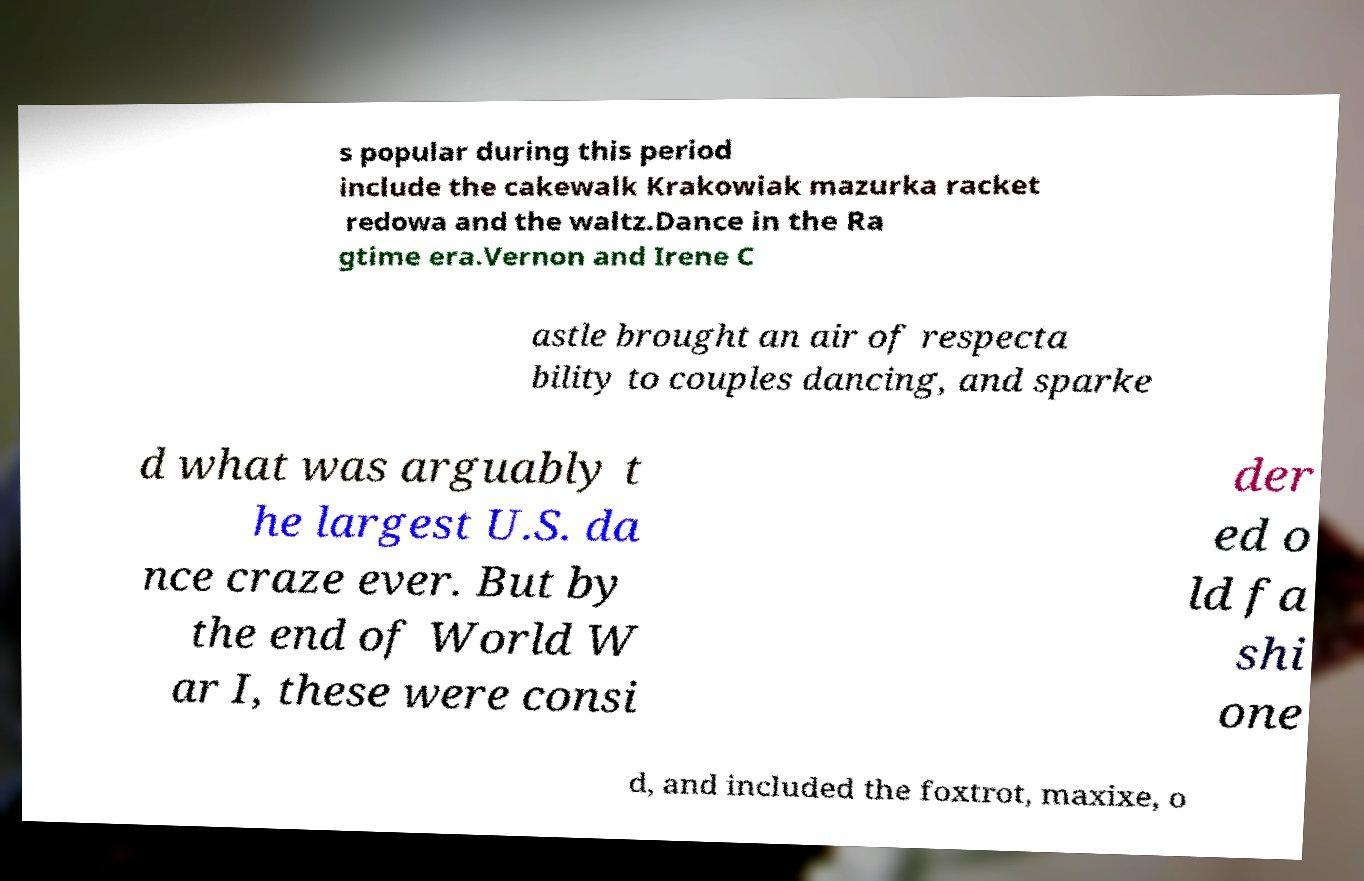Please read and relay the text visible in this image. What does it say? s popular during this period include the cakewalk Krakowiak mazurka racket redowa and the waltz.Dance in the Ra gtime era.Vernon and Irene C astle brought an air of respecta bility to couples dancing, and sparke d what was arguably t he largest U.S. da nce craze ever. But by the end of World W ar I, these were consi der ed o ld fa shi one d, and included the foxtrot, maxixe, o 